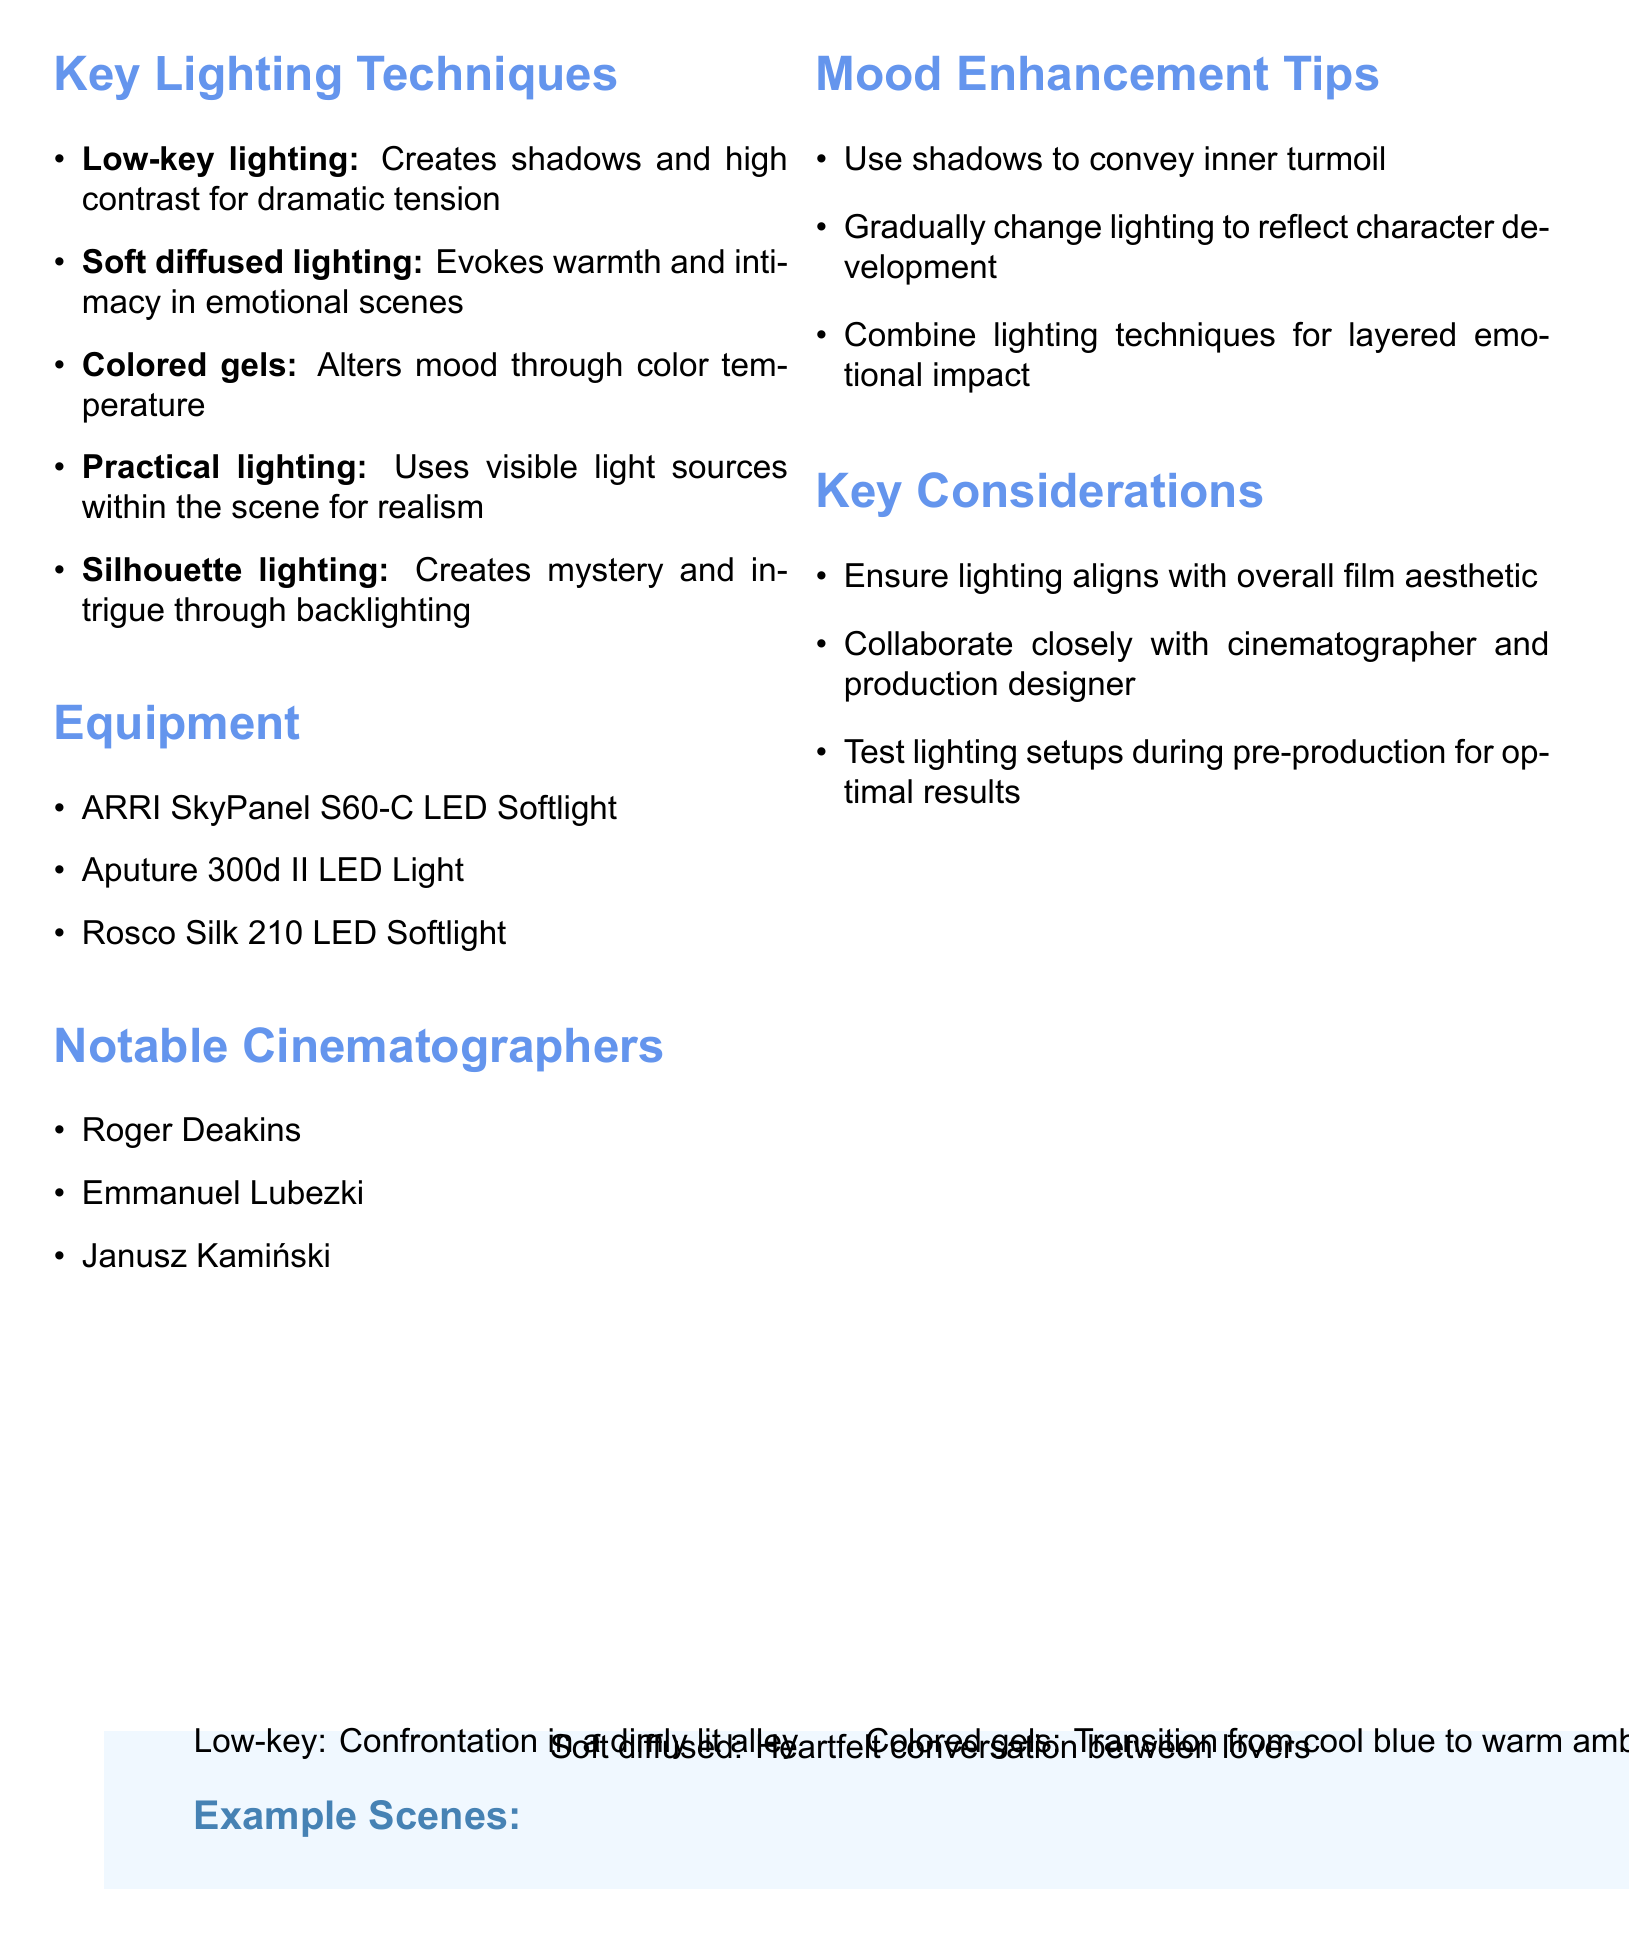What is the lighting technique that creates shadows and high contrast? The document states that low-key lighting is used to create shadows and high contrast for dramatic tension.
Answer: Low-key lighting What is an example scene for soft diffused lighting? According to the document, a heartfelt conversation between lovers is an example scene for soft diffused lighting.
Answer: Heartfelt conversation between lovers Which equipment is mentioned for soft lighting? The ARRI SkyPanel S60-C LED Softlight is one of the equipment items listed for soft lighting.
Answer: ARRI SkyPanel S60-C LED Softlight Who is a notable cinematographer listed in the document? The document lists Roger Deakins as one of the notable cinematographers.
Answer: Roger Deakins What mood enhancement tip suggests using shadows? The document recommends using shadows to convey inner turmoil as a mood enhancement tip.
Answer: Use shadows to convey inner turmoil How many key lighting techniques are described? The document describes five key lighting techniques.
Answer: Five What technique alters mood through color temperature? The document indicates that colored gels are used to alter mood through color temperature.
Answer: Colored gels Which lighting technique creates mystery and intrigue? Silhouette lighting is identified in the document as the technique that creates mystery and intrigue.
Answer: Silhouette lighting 